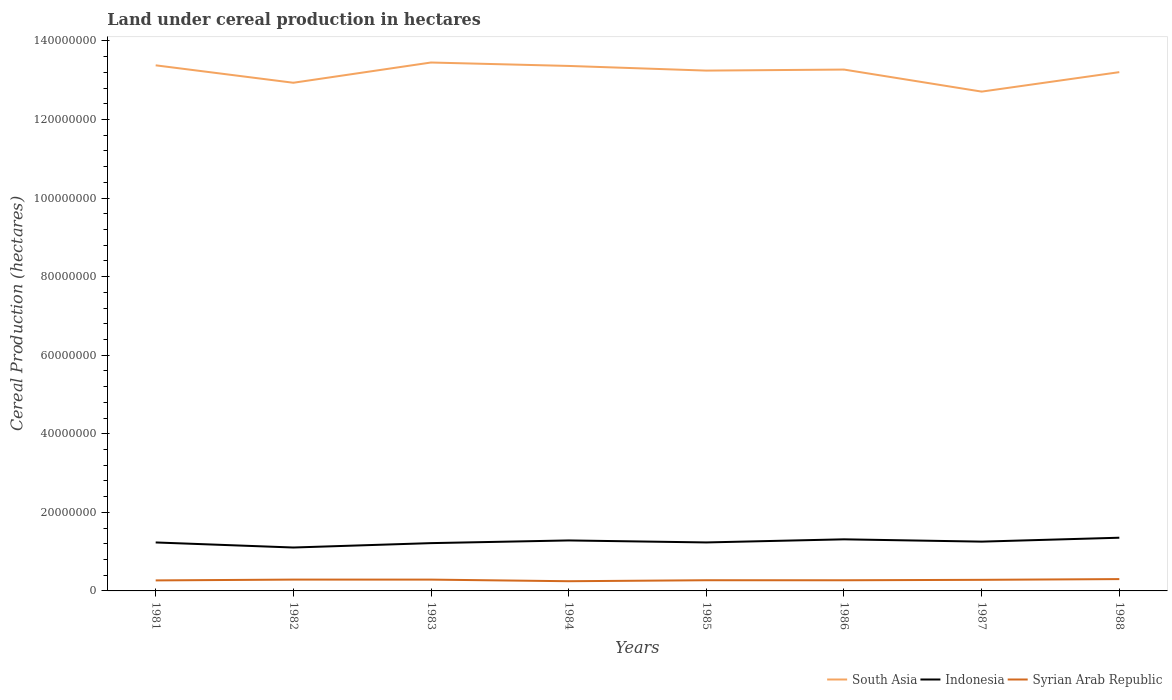Across all years, what is the maximum land under cereal production in South Asia?
Your answer should be compact. 1.27e+08. What is the total land under cereal production in South Asia in the graph?
Make the answer very short. 6.69e+06. What is the difference between the highest and the second highest land under cereal production in Indonesia?
Your answer should be compact. 2.49e+06. Is the land under cereal production in Indonesia strictly greater than the land under cereal production in South Asia over the years?
Your answer should be compact. Yes. How many lines are there?
Give a very brief answer. 3. How many years are there in the graph?
Your response must be concise. 8. What is the difference between two consecutive major ticks on the Y-axis?
Give a very brief answer. 2.00e+07. Does the graph contain any zero values?
Your answer should be very brief. No. Where does the legend appear in the graph?
Give a very brief answer. Bottom right. How are the legend labels stacked?
Give a very brief answer. Horizontal. What is the title of the graph?
Provide a succinct answer. Land under cereal production in hectares. Does "South Africa" appear as one of the legend labels in the graph?
Provide a succinct answer. No. What is the label or title of the X-axis?
Offer a very short reply. Years. What is the label or title of the Y-axis?
Your response must be concise. Cereal Production (hectares). What is the Cereal Production (hectares) in South Asia in 1981?
Offer a very short reply. 1.34e+08. What is the Cereal Production (hectares) in Indonesia in 1981?
Make the answer very short. 1.23e+07. What is the Cereal Production (hectares) of Syrian Arab Republic in 1981?
Keep it short and to the point. 2.68e+06. What is the Cereal Production (hectares) of South Asia in 1982?
Offer a very short reply. 1.29e+08. What is the Cereal Production (hectares) in Indonesia in 1982?
Your answer should be very brief. 1.10e+07. What is the Cereal Production (hectares) of Syrian Arab Republic in 1982?
Your answer should be compact. 2.88e+06. What is the Cereal Production (hectares) of South Asia in 1983?
Provide a short and direct response. 1.35e+08. What is the Cereal Production (hectares) in Indonesia in 1983?
Provide a short and direct response. 1.22e+07. What is the Cereal Production (hectares) of Syrian Arab Republic in 1983?
Provide a succinct answer. 2.88e+06. What is the Cereal Production (hectares) of South Asia in 1984?
Your response must be concise. 1.34e+08. What is the Cereal Production (hectares) in Indonesia in 1984?
Provide a short and direct response. 1.28e+07. What is the Cereal Production (hectares) of Syrian Arab Republic in 1984?
Your answer should be very brief. 2.47e+06. What is the Cereal Production (hectares) of South Asia in 1985?
Provide a succinct answer. 1.32e+08. What is the Cereal Production (hectares) of Indonesia in 1985?
Make the answer very short. 1.23e+07. What is the Cereal Production (hectares) of Syrian Arab Republic in 1985?
Provide a short and direct response. 2.72e+06. What is the Cereal Production (hectares) of South Asia in 1986?
Provide a succinct answer. 1.33e+08. What is the Cereal Production (hectares) in Indonesia in 1986?
Give a very brief answer. 1.31e+07. What is the Cereal Production (hectares) in Syrian Arab Republic in 1986?
Ensure brevity in your answer.  2.71e+06. What is the Cereal Production (hectares) in South Asia in 1987?
Keep it short and to the point. 1.27e+08. What is the Cereal Production (hectares) in Indonesia in 1987?
Give a very brief answer. 1.25e+07. What is the Cereal Production (hectares) of Syrian Arab Republic in 1987?
Give a very brief answer. 2.82e+06. What is the Cereal Production (hectares) of South Asia in 1988?
Keep it short and to the point. 1.32e+08. What is the Cereal Production (hectares) in Indonesia in 1988?
Keep it short and to the point. 1.35e+07. What is the Cereal Production (hectares) in Syrian Arab Republic in 1988?
Offer a terse response. 3.01e+06. Across all years, what is the maximum Cereal Production (hectares) of South Asia?
Your answer should be compact. 1.35e+08. Across all years, what is the maximum Cereal Production (hectares) in Indonesia?
Your answer should be very brief. 1.35e+07. Across all years, what is the maximum Cereal Production (hectares) of Syrian Arab Republic?
Provide a short and direct response. 3.01e+06. Across all years, what is the minimum Cereal Production (hectares) of South Asia?
Your answer should be compact. 1.27e+08. Across all years, what is the minimum Cereal Production (hectares) in Indonesia?
Offer a terse response. 1.10e+07. Across all years, what is the minimum Cereal Production (hectares) in Syrian Arab Republic?
Make the answer very short. 2.47e+06. What is the total Cereal Production (hectares) of South Asia in the graph?
Offer a very short reply. 1.06e+09. What is the total Cereal Production (hectares) of Indonesia in the graph?
Keep it short and to the point. 1.00e+08. What is the total Cereal Production (hectares) in Syrian Arab Republic in the graph?
Keep it short and to the point. 2.22e+07. What is the difference between the Cereal Production (hectares) in South Asia in 1981 and that in 1982?
Ensure brevity in your answer.  4.44e+06. What is the difference between the Cereal Production (hectares) of Indonesia in 1981 and that in 1982?
Provide a succinct answer. 1.29e+06. What is the difference between the Cereal Production (hectares) of Syrian Arab Republic in 1981 and that in 1982?
Your answer should be compact. -2.07e+05. What is the difference between the Cereal Production (hectares) in South Asia in 1981 and that in 1983?
Offer a terse response. -7.17e+05. What is the difference between the Cereal Production (hectares) of Indonesia in 1981 and that in 1983?
Offer a terse response. 1.72e+05. What is the difference between the Cereal Production (hectares) of Syrian Arab Republic in 1981 and that in 1983?
Provide a short and direct response. -2.04e+05. What is the difference between the Cereal Production (hectares) in South Asia in 1981 and that in 1984?
Give a very brief answer. 1.54e+05. What is the difference between the Cereal Production (hectares) of Indonesia in 1981 and that in 1984?
Your answer should be compact. -5.13e+05. What is the difference between the Cereal Production (hectares) of Syrian Arab Republic in 1981 and that in 1984?
Your response must be concise. 2.05e+05. What is the difference between the Cereal Production (hectares) in South Asia in 1981 and that in 1985?
Keep it short and to the point. 1.34e+06. What is the difference between the Cereal Production (hectares) of Indonesia in 1981 and that in 1985?
Your answer should be very brief. -5381. What is the difference between the Cereal Production (hectares) of Syrian Arab Republic in 1981 and that in 1985?
Your answer should be compact. -4.33e+04. What is the difference between the Cereal Production (hectares) in South Asia in 1981 and that in 1986?
Your answer should be very brief. 1.08e+06. What is the difference between the Cereal Production (hectares) in Indonesia in 1981 and that in 1986?
Your answer should be very brief. -7.94e+05. What is the difference between the Cereal Production (hectares) of Syrian Arab Republic in 1981 and that in 1986?
Make the answer very short. -3.76e+04. What is the difference between the Cereal Production (hectares) in South Asia in 1981 and that in 1987?
Provide a succinct answer. 6.69e+06. What is the difference between the Cereal Production (hectares) in Indonesia in 1981 and that in 1987?
Offer a very short reply. -2.12e+05. What is the difference between the Cereal Production (hectares) in Syrian Arab Republic in 1981 and that in 1987?
Ensure brevity in your answer.  -1.48e+05. What is the difference between the Cereal Production (hectares) in South Asia in 1981 and that in 1988?
Your response must be concise. 1.73e+06. What is the difference between the Cereal Production (hectares) of Indonesia in 1981 and that in 1988?
Give a very brief answer. -1.21e+06. What is the difference between the Cereal Production (hectares) of Syrian Arab Republic in 1981 and that in 1988?
Give a very brief answer. -3.36e+05. What is the difference between the Cereal Production (hectares) in South Asia in 1982 and that in 1983?
Give a very brief answer. -5.15e+06. What is the difference between the Cereal Production (hectares) of Indonesia in 1982 and that in 1983?
Provide a succinct answer. -1.11e+06. What is the difference between the Cereal Production (hectares) of Syrian Arab Republic in 1982 and that in 1983?
Ensure brevity in your answer.  2786. What is the difference between the Cereal Production (hectares) of South Asia in 1982 and that in 1984?
Ensure brevity in your answer.  -4.28e+06. What is the difference between the Cereal Production (hectares) of Indonesia in 1982 and that in 1984?
Provide a short and direct response. -1.80e+06. What is the difference between the Cereal Production (hectares) of Syrian Arab Republic in 1982 and that in 1984?
Keep it short and to the point. 4.11e+05. What is the difference between the Cereal Production (hectares) of South Asia in 1982 and that in 1985?
Ensure brevity in your answer.  -3.10e+06. What is the difference between the Cereal Production (hectares) of Indonesia in 1982 and that in 1985?
Make the answer very short. -1.29e+06. What is the difference between the Cereal Production (hectares) in Syrian Arab Republic in 1982 and that in 1985?
Your response must be concise. 1.63e+05. What is the difference between the Cereal Production (hectares) of South Asia in 1982 and that in 1986?
Ensure brevity in your answer.  -3.36e+06. What is the difference between the Cereal Production (hectares) of Indonesia in 1982 and that in 1986?
Ensure brevity in your answer.  -2.08e+06. What is the difference between the Cereal Production (hectares) of Syrian Arab Republic in 1982 and that in 1986?
Provide a succinct answer. 1.69e+05. What is the difference between the Cereal Production (hectares) in South Asia in 1982 and that in 1987?
Keep it short and to the point. 2.25e+06. What is the difference between the Cereal Production (hectares) in Indonesia in 1982 and that in 1987?
Provide a succinct answer. -1.50e+06. What is the difference between the Cereal Production (hectares) of Syrian Arab Republic in 1982 and that in 1987?
Keep it short and to the point. 5.90e+04. What is the difference between the Cereal Production (hectares) in South Asia in 1982 and that in 1988?
Provide a short and direct response. -2.70e+06. What is the difference between the Cereal Production (hectares) in Indonesia in 1982 and that in 1988?
Offer a terse response. -2.49e+06. What is the difference between the Cereal Production (hectares) of Syrian Arab Republic in 1982 and that in 1988?
Your response must be concise. -1.29e+05. What is the difference between the Cereal Production (hectares) in South Asia in 1983 and that in 1984?
Make the answer very short. 8.71e+05. What is the difference between the Cereal Production (hectares) of Indonesia in 1983 and that in 1984?
Your answer should be compact. -6.85e+05. What is the difference between the Cereal Production (hectares) of Syrian Arab Republic in 1983 and that in 1984?
Your answer should be compact. 4.09e+05. What is the difference between the Cereal Production (hectares) in South Asia in 1983 and that in 1985?
Offer a very short reply. 2.06e+06. What is the difference between the Cereal Production (hectares) in Indonesia in 1983 and that in 1985?
Provide a succinct answer. -1.78e+05. What is the difference between the Cereal Production (hectares) in Syrian Arab Republic in 1983 and that in 1985?
Make the answer very short. 1.60e+05. What is the difference between the Cereal Production (hectares) in South Asia in 1983 and that in 1986?
Provide a succinct answer. 1.79e+06. What is the difference between the Cereal Production (hectares) in Indonesia in 1983 and that in 1986?
Your response must be concise. -9.67e+05. What is the difference between the Cereal Production (hectares) in Syrian Arab Republic in 1983 and that in 1986?
Provide a short and direct response. 1.66e+05. What is the difference between the Cereal Production (hectares) in South Asia in 1983 and that in 1987?
Provide a succinct answer. 7.41e+06. What is the difference between the Cereal Production (hectares) in Indonesia in 1983 and that in 1987?
Your answer should be very brief. -3.84e+05. What is the difference between the Cereal Production (hectares) in Syrian Arab Republic in 1983 and that in 1987?
Your response must be concise. 5.62e+04. What is the difference between the Cereal Production (hectares) in South Asia in 1983 and that in 1988?
Your answer should be compact. 2.45e+06. What is the difference between the Cereal Production (hectares) in Indonesia in 1983 and that in 1988?
Offer a terse response. -1.38e+06. What is the difference between the Cereal Production (hectares) in Syrian Arab Republic in 1983 and that in 1988?
Your response must be concise. -1.32e+05. What is the difference between the Cereal Production (hectares) of South Asia in 1984 and that in 1985?
Make the answer very short. 1.19e+06. What is the difference between the Cereal Production (hectares) of Indonesia in 1984 and that in 1985?
Keep it short and to the point. 5.08e+05. What is the difference between the Cereal Production (hectares) of Syrian Arab Republic in 1984 and that in 1985?
Provide a short and direct response. -2.48e+05. What is the difference between the Cereal Production (hectares) of South Asia in 1984 and that in 1986?
Your response must be concise. 9.24e+05. What is the difference between the Cereal Production (hectares) of Indonesia in 1984 and that in 1986?
Offer a terse response. -2.81e+05. What is the difference between the Cereal Production (hectares) in Syrian Arab Republic in 1984 and that in 1986?
Your answer should be compact. -2.42e+05. What is the difference between the Cereal Production (hectares) of South Asia in 1984 and that in 1987?
Offer a very short reply. 6.54e+06. What is the difference between the Cereal Production (hectares) in Indonesia in 1984 and that in 1987?
Your response must be concise. 3.01e+05. What is the difference between the Cereal Production (hectares) in Syrian Arab Republic in 1984 and that in 1987?
Make the answer very short. -3.52e+05. What is the difference between the Cereal Production (hectares) of South Asia in 1984 and that in 1988?
Make the answer very short. 1.58e+06. What is the difference between the Cereal Production (hectares) in Indonesia in 1984 and that in 1988?
Make the answer very short. -6.94e+05. What is the difference between the Cereal Production (hectares) in Syrian Arab Republic in 1984 and that in 1988?
Your answer should be compact. -5.41e+05. What is the difference between the Cereal Production (hectares) of South Asia in 1985 and that in 1986?
Your response must be concise. -2.65e+05. What is the difference between the Cereal Production (hectares) in Indonesia in 1985 and that in 1986?
Offer a very short reply. -7.89e+05. What is the difference between the Cereal Production (hectares) in Syrian Arab Republic in 1985 and that in 1986?
Give a very brief answer. 5741. What is the difference between the Cereal Production (hectares) of South Asia in 1985 and that in 1987?
Offer a very short reply. 5.35e+06. What is the difference between the Cereal Production (hectares) in Indonesia in 1985 and that in 1987?
Your response must be concise. -2.06e+05. What is the difference between the Cereal Production (hectares) of Syrian Arab Republic in 1985 and that in 1987?
Offer a terse response. -1.04e+05. What is the difference between the Cereal Production (hectares) of South Asia in 1985 and that in 1988?
Offer a terse response. 3.92e+05. What is the difference between the Cereal Production (hectares) in Indonesia in 1985 and that in 1988?
Provide a succinct answer. -1.20e+06. What is the difference between the Cereal Production (hectares) of Syrian Arab Republic in 1985 and that in 1988?
Offer a very short reply. -2.92e+05. What is the difference between the Cereal Production (hectares) in South Asia in 1986 and that in 1987?
Offer a very short reply. 5.61e+06. What is the difference between the Cereal Production (hectares) of Indonesia in 1986 and that in 1987?
Your answer should be very brief. 5.83e+05. What is the difference between the Cereal Production (hectares) in Syrian Arab Republic in 1986 and that in 1987?
Provide a succinct answer. -1.10e+05. What is the difference between the Cereal Production (hectares) of South Asia in 1986 and that in 1988?
Your answer should be compact. 6.57e+05. What is the difference between the Cereal Production (hectares) in Indonesia in 1986 and that in 1988?
Make the answer very short. -4.13e+05. What is the difference between the Cereal Production (hectares) of Syrian Arab Republic in 1986 and that in 1988?
Offer a very short reply. -2.98e+05. What is the difference between the Cereal Production (hectares) in South Asia in 1987 and that in 1988?
Offer a terse response. -4.96e+06. What is the difference between the Cereal Production (hectares) in Indonesia in 1987 and that in 1988?
Your answer should be compact. -9.95e+05. What is the difference between the Cereal Production (hectares) of Syrian Arab Republic in 1987 and that in 1988?
Your answer should be compact. -1.88e+05. What is the difference between the Cereal Production (hectares) of South Asia in 1981 and the Cereal Production (hectares) of Indonesia in 1982?
Provide a succinct answer. 1.23e+08. What is the difference between the Cereal Production (hectares) of South Asia in 1981 and the Cereal Production (hectares) of Syrian Arab Republic in 1982?
Keep it short and to the point. 1.31e+08. What is the difference between the Cereal Production (hectares) in Indonesia in 1981 and the Cereal Production (hectares) in Syrian Arab Republic in 1982?
Offer a very short reply. 9.45e+06. What is the difference between the Cereal Production (hectares) in South Asia in 1981 and the Cereal Production (hectares) in Indonesia in 1983?
Your answer should be compact. 1.22e+08. What is the difference between the Cereal Production (hectares) in South Asia in 1981 and the Cereal Production (hectares) in Syrian Arab Republic in 1983?
Your response must be concise. 1.31e+08. What is the difference between the Cereal Production (hectares) in Indonesia in 1981 and the Cereal Production (hectares) in Syrian Arab Republic in 1983?
Give a very brief answer. 9.46e+06. What is the difference between the Cereal Production (hectares) in South Asia in 1981 and the Cereal Production (hectares) in Indonesia in 1984?
Give a very brief answer. 1.21e+08. What is the difference between the Cereal Production (hectares) of South Asia in 1981 and the Cereal Production (hectares) of Syrian Arab Republic in 1984?
Provide a succinct answer. 1.31e+08. What is the difference between the Cereal Production (hectares) of Indonesia in 1981 and the Cereal Production (hectares) of Syrian Arab Republic in 1984?
Give a very brief answer. 9.87e+06. What is the difference between the Cereal Production (hectares) of South Asia in 1981 and the Cereal Production (hectares) of Indonesia in 1985?
Provide a short and direct response. 1.21e+08. What is the difference between the Cereal Production (hectares) in South Asia in 1981 and the Cereal Production (hectares) in Syrian Arab Republic in 1985?
Make the answer very short. 1.31e+08. What is the difference between the Cereal Production (hectares) in Indonesia in 1981 and the Cereal Production (hectares) in Syrian Arab Republic in 1985?
Make the answer very short. 9.62e+06. What is the difference between the Cereal Production (hectares) of South Asia in 1981 and the Cereal Production (hectares) of Indonesia in 1986?
Your answer should be very brief. 1.21e+08. What is the difference between the Cereal Production (hectares) of South Asia in 1981 and the Cereal Production (hectares) of Syrian Arab Republic in 1986?
Provide a succinct answer. 1.31e+08. What is the difference between the Cereal Production (hectares) in Indonesia in 1981 and the Cereal Production (hectares) in Syrian Arab Republic in 1986?
Your response must be concise. 9.62e+06. What is the difference between the Cereal Production (hectares) in South Asia in 1981 and the Cereal Production (hectares) in Indonesia in 1987?
Provide a short and direct response. 1.21e+08. What is the difference between the Cereal Production (hectares) of South Asia in 1981 and the Cereal Production (hectares) of Syrian Arab Republic in 1987?
Make the answer very short. 1.31e+08. What is the difference between the Cereal Production (hectares) of Indonesia in 1981 and the Cereal Production (hectares) of Syrian Arab Republic in 1987?
Your answer should be compact. 9.51e+06. What is the difference between the Cereal Production (hectares) of South Asia in 1981 and the Cereal Production (hectares) of Indonesia in 1988?
Your response must be concise. 1.20e+08. What is the difference between the Cereal Production (hectares) of South Asia in 1981 and the Cereal Production (hectares) of Syrian Arab Republic in 1988?
Your answer should be compact. 1.31e+08. What is the difference between the Cereal Production (hectares) of Indonesia in 1981 and the Cereal Production (hectares) of Syrian Arab Republic in 1988?
Your answer should be compact. 9.32e+06. What is the difference between the Cereal Production (hectares) in South Asia in 1982 and the Cereal Production (hectares) in Indonesia in 1983?
Provide a succinct answer. 1.17e+08. What is the difference between the Cereal Production (hectares) in South Asia in 1982 and the Cereal Production (hectares) in Syrian Arab Republic in 1983?
Give a very brief answer. 1.26e+08. What is the difference between the Cereal Production (hectares) in Indonesia in 1982 and the Cereal Production (hectares) in Syrian Arab Republic in 1983?
Make the answer very short. 8.17e+06. What is the difference between the Cereal Production (hectares) of South Asia in 1982 and the Cereal Production (hectares) of Indonesia in 1984?
Keep it short and to the point. 1.16e+08. What is the difference between the Cereal Production (hectares) of South Asia in 1982 and the Cereal Production (hectares) of Syrian Arab Republic in 1984?
Ensure brevity in your answer.  1.27e+08. What is the difference between the Cereal Production (hectares) of Indonesia in 1982 and the Cereal Production (hectares) of Syrian Arab Republic in 1984?
Offer a terse response. 8.58e+06. What is the difference between the Cereal Production (hectares) in South Asia in 1982 and the Cereal Production (hectares) in Indonesia in 1985?
Offer a terse response. 1.17e+08. What is the difference between the Cereal Production (hectares) in South Asia in 1982 and the Cereal Production (hectares) in Syrian Arab Republic in 1985?
Provide a short and direct response. 1.27e+08. What is the difference between the Cereal Production (hectares) of Indonesia in 1982 and the Cereal Production (hectares) of Syrian Arab Republic in 1985?
Provide a succinct answer. 8.33e+06. What is the difference between the Cereal Production (hectares) in South Asia in 1982 and the Cereal Production (hectares) in Indonesia in 1986?
Ensure brevity in your answer.  1.16e+08. What is the difference between the Cereal Production (hectares) in South Asia in 1982 and the Cereal Production (hectares) in Syrian Arab Republic in 1986?
Offer a terse response. 1.27e+08. What is the difference between the Cereal Production (hectares) in Indonesia in 1982 and the Cereal Production (hectares) in Syrian Arab Republic in 1986?
Provide a short and direct response. 8.34e+06. What is the difference between the Cereal Production (hectares) in South Asia in 1982 and the Cereal Production (hectares) in Indonesia in 1987?
Ensure brevity in your answer.  1.17e+08. What is the difference between the Cereal Production (hectares) of South Asia in 1982 and the Cereal Production (hectares) of Syrian Arab Republic in 1987?
Your response must be concise. 1.27e+08. What is the difference between the Cereal Production (hectares) of Indonesia in 1982 and the Cereal Production (hectares) of Syrian Arab Republic in 1987?
Keep it short and to the point. 8.23e+06. What is the difference between the Cereal Production (hectares) of South Asia in 1982 and the Cereal Production (hectares) of Indonesia in 1988?
Provide a short and direct response. 1.16e+08. What is the difference between the Cereal Production (hectares) of South Asia in 1982 and the Cereal Production (hectares) of Syrian Arab Republic in 1988?
Provide a succinct answer. 1.26e+08. What is the difference between the Cereal Production (hectares) of Indonesia in 1982 and the Cereal Production (hectares) of Syrian Arab Republic in 1988?
Provide a short and direct response. 8.04e+06. What is the difference between the Cereal Production (hectares) of South Asia in 1983 and the Cereal Production (hectares) of Indonesia in 1984?
Offer a very short reply. 1.22e+08. What is the difference between the Cereal Production (hectares) in South Asia in 1983 and the Cereal Production (hectares) in Syrian Arab Republic in 1984?
Make the answer very short. 1.32e+08. What is the difference between the Cereal Production (hectares) in Indonesia in 1983 and the Cereal Production (hectares) in Syrian Arab Republic in 1984?
Provide a short and direct response. 9.69e+06. What is the difference between the Cereal Production (hectares) in South Asia in 1983 and the Cereal Production (hectares) in Indonesia in 1985?
Provide a succinct answer. 1.22e+08. What is the difference between the Cereal Production (hectares) of South Asia in 1983 and the Cereal Production (hectares) of Syrian Arab Republic in 1985?
Your answer should be very brief. 1.32e+08. What is the difference between the Cereal Production (hectares) of Indonesia in 1983 and the Cereal Production (hectares) of Syrian Arab Republic in 1985?
Keep it short and to the point. 9.45e+06. What is the difference between the Cereal Production (hectares) in South Asia in 1983 and the Cereal Production (hectares) in Indonesia in 1986?
Offer a very short reply. 1.21e+08. What is the difference between the Cereal Production (hectares) in South Asia in 1983 and the Cereal Production (hectares) in Syrian Arab Republic in 1986?
Your answer should be compact. 1.32e+08. What is the difference between the Cereal Production (hectares) in Indonesia in 1983 and the Cereal Production (hectares) in Syrian Arab Republic in 1986?
Ensure brevity in your answer.  9.45e+06. What is the difference between the Cereal Production (hectares) in South Asia in 1983 and the Cereal Production (hectares) in Indonesia in 1987?
Provide a succinct answer. 1.22e+08. What is the difference between the Cereal Production (hectares) of South Asia in 1983 and the Cereal Production (hectares) of Syrian Arab Republic in 1987?
Offer a terse response. 1.32e+08. What is the difference between the Cereal Production (hectares) in Indonesia in 1983 and the Cereal Production (hectares) in Syrian Arab Republic in 1987?
Your response must be concise. 9.34e+06. What is the difference between the Cereal Production (hectares) of South Asia in 1983 and the Cereal Production (hectares) of Indonesia in 1988?
Offer a very short reply. 1.21e+08. What is the difference between the Cereal Production (hectares) in South Asia in 1983 and the Cereal Production (hectares) in Syrian Arab Republic in 1988?
Keep it short and to the point. 1.31e+08. What is the difference between the Cereal Production (hectares) of Indonesia in 1983 and the Cereal Production (hectares) of Syrian Arab Republic in 1988?
Your answer should be very brief. 9.15e+06. What is the difference between the Cereal Production (hectares) in South Asia in 1984 and the Cereal Production (hectares) in Indonesia in 1985?
Offer a terse response. 1.21e+08. What is the difference between the Cereal Production (hectares) in South Asia in 1984 and the Cereal Production (hectares) in Syrian Arab Republic in 1985?
Give a very brief answer. 1.31e+08. What is the difference between the Cereal Production (hectares) in Indonesia in 1984 and the Cereal Production (hectares) in Syrian Arab Republic in 1985?
Give a very brief answer. 1.01e+07. What is the difference between the Cereal Production (hectares) of South Asia in 1984 and the Cereal Production (hectares) of Indonesia in 1986?
Offer a terse response. 1.21e+08. What is the difference between the Cereal Production (hectares) in South Asia in 1984 and the Cereal Production (hectares) in Syrian Arab Republic in 1986?
Give a very brief answer. 1.31e+08. What is the difference between the Cereal Production (hectares) of Indonesia in 1984 and the Cereal Production (hectares) of Syrian Arab Republic in 1986?
Provide a short and direct response. 1.01e+07. What is the difference between the Cereal Production (hectares) in South Asia in 1984 and the Cereal Production (hectares) in Indonesia in 1987?
Ensure brevity in your answer.  1.21e+08. What is the difference between the Cereal Production (hectares) in South Asia in 1984 and the Cereal Production (hectares) in Syrian Arab Republic in 1987?
Offer a terse response. 1.31e+08. What is the difference between the Cereal Production (hectares) of Indonesia in 1984 and the Cereal Production (hectares) of Syrian Arab Republic in 1987?
Your response must be concise. 1.00e+07. What is the difference between the Cereal Production (hectares) of South Asia in 1984 and the Cereal Production (hectares) of Indonesia in 1988?
Ensure brevity in your answer.  1.20e+08. What is the difference between the Cereal Production (hectares) of South Asia in 1984 and the Cereal Production (hectares) of Syrian Arab Republic in 1988?
Offer a terse response. 1.31e+08. What is the difference between the Cereal Production (hectares) of Indonesia in 1984 and the Cereal Production (hectares) of Syrian Arab Republic in 1988?
Give a very brief answer. 9.84e+06. What is the difference between the Cereal Production (hectares) of South Asia in 1985 and the Cereal Production (hectares) of Indonesia in 1986?
Your answer should be compact. 1.19e+08. What is the difference between the Cereal Production (hectares) in South Asia in 1985 and the Cereal Production (hectares) in Syrian Arab Republic in 1986?
Your answer should be compact. 1.30e+08. What is the difference between the Cereal Production (hectares) of Indonesia in 1985 and the Cereal Production (hectares) of Syrian Arab Republic in 1986?
Your response must be concise. 9.63e+06. What is the difference between the Cereal Production (hectares) in South Asia in 1985 and the Cereal Production (hectares) in Indonesia in 1987?
Give a very brief answer. 1.20e+08. What is the difference between the Cereal Production (hectares) of South Asia in 1985 and the Cereal Production (hectares) of Syrian Arab Republic in 1987?
Your answer should be very brief. 1.30e+08. What is the difference between the Cereal Production (hectares) of Indonesia in 1985 and the Cereal Production (hectares) of Syrian Arab Republic in 1987?
Your answer should be very brief. 9.52e+06. What is the difference between the Cereal Production (hectares) of South Asia in 1985 and the Cereal Production (hectares) of Indonesia in 1988?
Offer a very short reply. 1.19e+08. What is the difference between the Cereal Production (hectares) of South Asia in 1985 and the Cereal Production (hectares) of Syrian Arab Republic in 1988?
Give a very brief answer. 1.29e+08. What is the difference between the Cereal Production (hectares) of Indonesia in 1985 and the Cereal Production (hectares) of Syrian Arab Republic in 1988?
Provide a short and direct response. 9.33e+06. What is the difference between the Cereal Production (hectares) in South Asia in 1986 and the Cereal Production (hectares) in Indonesia in 1987?
Make the answer very short. 1.20e+08. What is the difference between the Cereal Production (hectares) of South Asia in 1986 and the Cereal Production (hectares) of Syrian Arab Republic in 1987?
Your response must be concise. 1.30e+08. What is the difference between the Cereal Production (hectares) of Indonesia in 1986 and the Cereal Production (hectares) of Syrian Arab Republic in 1987?
Your answer should be very brief. 1.03e+07. What is the difference between the Cereal Production (hectares) in South Asia in 1986 and the Cereal Production (hectares) in Indonesia in 1988?
Your answer should be very brief. 1.19e+08. What is the difference between the Cereal Production (hectares) of South Asia in 1986 and the Cereal Production (hectares) of Syrian Arab Republic in 1988?
Your response must be concise. 1.30e+08. What is the difference between the Cereal Production (hectares) in Indonesia in 1986 and the Cereal Production (hectares) in Syrian Arab Republic in 1988?
Give a very brief answer. 1.01e+07. What is the difference between the Cereal Production (hectares) in South Asia in 1987 and the Cereal Production (hectares) in Indonesia in 1988?
Offer a very short reply. 1.14e+08. What is the difference between the Cereal Production (hectares) in South Asia in 1987 and the Cereal Production (hectares) in Syrian Arab Republic in 1988?
Keep it short and to the point. 1.24e+08. What is the difference between the Cereal Production (hectares) of Indonesia in 1987 and the Cereal Production (hectares) of Syrian Arab Republic in 1988?
Your answer should be very brief. 9.54e+06. What is the average Cereal Production (hectares) of South Asia per year?
Keep it short and to the point. 1.32e+08. What is the average Cereal Production (hectares) of Indonesia per year?
Your response must be concise. 1.25e+07. What is the average Cereal Production (hectares) of Syrian Arab Republic per year?
Keep it short and to the point. 2.77e+06. In the year 1981, what is the difference between the Cereal Production (hectares) of South Asia and Cereal Production (hectares) of Indonesia?
Provide a short and direct response. 1.21e+08. In the year 1981, what is the difference between the Cereal Production (hectares) of South Asia and Cereal Production (hectares) of Syrian Arab Republic?
Provide a succinct answer. 1.31e+08. In the year 1981, what is the difference between the Cereal Production (hectares) in Indonesia and Cereal Production (hectares) in Syrian Arab Republic?
Your answer should be very brief. 9.66e+06. In the year 1982, what is the difference between the Cereal Production (hectares) in South Asia and Cereal Production (hectares) in Indonesia?
Your answer should be very brief. 1.18e+08. In the year 1982, what is the difference between the Cereal Production (hectares) of South Asia and Cereal Production (hectares) of Syrian Arab Republic?
Ensure brevity in your answer.  1.26e+08. In the year 1982, what is the difference between the Cereal Production (hectares) in Indonesia and Cereal Production (hectares) in Syrian Arab Republic?
Ensure brevity in your answer.  8.17e+06. In the year 1983, what is the difference between the Cereal Production (hectares) of South Asia and Cereal Production (hectares) of Indonesia?
Your answer should be compact. 1.22e+08. In the year 1983, what is the difference between the Cereal Production (hectares) in South Asia and Cereal Production (hectares) in Syrian Arab Republic?
Make the answer very short. 1.32e+08. In the year 1983, what is the difference between the Cereal Production (hectares) in Indonesia and Cereal Production (hectares) in Syrian Arab Republic?
Provide a succinct answer. 9.28e+06. In the year 1984, what is the difference between the Cereal Production (hectares) of South Asia and Cereal Production (hectares) of Indonesia?
Offer a very short reply. 1.21e+08. In the year 1984, what is the difference between the Cereal Production (hectares) in South Asia and Cereal Production (hectares) in Syrian Arab Republic?
Provide a short and direct response. 1.31e+08. In the year 1984, what is the difference between the Cereal Production (hectares) in Indonesia and Cereal Production (hectares) in Syrian Arab Republic?
Give a very brief answer. 1.04e+07. In the year 1985, what is the difference between the Cereal Production (hectares) of South Asia and Cereal Production (hectares) of Indonesia?
Offer a very short reply. 1.20e+08. In the year 1985, what is the difference between the Cereal Production (hectares) in South Asia and Cereal Production (hectares) in Syrian Arab Republic?
Make the answer very short. 1.30e+08. In the year 1985, what is the difference between the Cereal Production (hectares) in Indonesia and Cereal Production (hectares) in Syrian Arab Republic?
Your answer should be compact. 9.62e+06. In the year 1986, what is the difference between the Cereal Production (hectares) in South Asia and Cereal Production (hectares) in Indonesia?
Give a very brief answer. 1.20e+08. In the year 1986, what is the difference between the Cereal Production (hectares) of South Asia and Cereal Production (hectares) of Syrian Arab Republic?
Your answer should be very brief. 1.30e+08. In the year 1986, what is the difference between the Cereal Production (hectares) of Indonesia and Cereal Production (hectares) of Syrian Arab Republic?
Ensure brevity in your answer.  1.04e+07. In the year 1987, what is the difference between the Cereal Production (hectares) of South Asia and Cereal Production (hectares) of Indonesia?
Give a very brief answer. 1.15e+08. In the year 1987, what is the difference between the Cereal Production (hectares) of South Asia and Cereal Production (hectares) of Syrian Arab Republic?
Provide a short and direct response. 1.24e+08. In the year 1987, what is the difference between the Cereal Production (hectares) of Indonesia and Cereal Production (hectares) of Syrian Arab Republic?
Your answer should be compact. 9.72e+06. In the year 1988, what is the difference between the Cereal Production (hectares) of South Asia and Cereal Production (hectares) of Indonesia?
Ensure brevity in your answer.  1.19e+08. In the year 1988, what is the difference between the Cereal Production (hectares) of South Asia and Cereal Production (hectares) of Syrian Arab Republic?
Give a very brief answer. 1.29e+08. In the year 1988, what is the difference between the Cereal Production (hectares) of Indonesia and Cereal Production (hectares) of Syrian Arab Republic?
Your answer should be compact. 1.05e+07. What is the ratio of the Cereal Production (hectares) of South Asia in 1981 to that in 1982?
Give a very brief answer. 1.03. What is the ratio of the Cereal Production (hectares) in Indonesia in 1981 to that in 1982?
Your answer should be compact. 1.12. What is the ratio of the Cereal Production (hectares) in Syrian Arab Republic in 1981 to that in 1982?
Keep it short and to the point. 0.93. What is the ratio of the Cereal Production (hectares) of Indonesia in 1981 to that in 1983?
Offer a very short reply. 1.01. What is the ratio of the Cereal Production (hectares) of Syrian Arab Republic in 1981 to that in 1983?
Keep it short and to the point. 0.93. What is the ratio of the Cereal Production (hectares) in Indonesia in 1981 to that in 1984?
Provide a short and direct response. 0.96. What is the ratio of the Cereal Production (hectares) in Syrian Arab Republic in 1981 to that in 1984?
Ensure brevity in your answer.  1.08. What is the ratio of the Cereal Production (hectares) in South Asia in 1981 to that in 1985?
Make the answer very short. 1.01. What is the ratio of the Cereal Production (hectares) of Indonesia in 1981 to that in 1985?
Offer a very short reply. 1. What is the ratio of the Cereal Production (hectares) of Syrian Arab Republic in 1981 to that in 1985?
Ensure brevity in your answer.  0.98. What is the ratio of the Cereal Production (hectares) of Indonesia in 1981 to that in 1986?
Your answer should be very brief. 0.94. What is the ratio of the Cereal Production (hectares) of Syrian Arab Republic in 1981 to that in 1986?
Make the answer very short. 0.99. What is the ratio of the Cereal Production (hectares) in South Asia in 1981 to that in 1987?
Offer a terse response. 1.05. What is the ratio of the Cereal Production (hectares) in Indonesia in 1981 to that in 1987?
Your answer should be very brief. 0.98. What is the ratio of the Cereal Production (hectares) in Syrian Arab Republic in 1981 to that in 1987?
Provide a short and direct response. 0.95. What is the ratio of the Cereal Production (hectares) in South Asia in 1981 to that in 1988?
Offer a terse response. 1.01. What is the ratio of the Cereal Production (hectares) in Indonesia in 1981 to that in 1988?
Your answer should be compact. 0.91. What is the ratio of the Cereal Production (hectares) in Syrian Arab Republic in 1981 to that in 1988?
Give a very brief answer. 0.89. What is the ratio of the Cereal Production (hectares) in South Asia in 1982 to that in 1983?
Your answer should be compact. 0.96. What is the ratio of the Cereal Production (hectares) in Indonesia in 1982 to that in 1983?
Offer a terse response. 0.91. What is the ratio of the Cereal Production (hectares) in South Asia in 1982 to that in 1984?
Provide a succinct answer. 0.97. What is the ratio of the Cereal Production (hectares) of Indonesia in 1982 to that in 1984?
Give a very brief answer. 0.86. What is the ratio of the Cereal Production (hectares) of Syrian Arab Republic in 1982 to that in 1984?
Provide a succinct answer. 1.17. What is the ratio of the Cereal Production (hectares) in South Asia in 1982 to that in 1985?
Ensure brevity in your answer.  0.98. What is the ratio of the Cereal Production (hectares) in Indonesia in 1982 to that in 1985?
Offer a terse response. 0.9. What is the ratio of the Cereal Production (hectares) of Syrian Arab Republic in 1982 to that in 1985?
Make the answer very short. 1.06. What is the ratio of the Cereal Production (hectares) of South Asia in 1982 to that in 1986?
Your answer should be very brief. 0.97. What is the ratio of the Cereal Production (hectares) of Indonesia in 1982 to that in 1986?
Your response must be concise. 0.84. What is the ratio of the Cereal Production (hectares) in Syrian Arab Republic in 1982 to that in 1986?
Provide a succinct answer. 1.06. What is the ratio of the Cereal Production (hectares) in South Asia in 1982 to that in 1987?
Your answer should be compact. 1.02. What is the ratio of the Cereal Production (hectares) of Indonesia in 1982 to that in 1987?
Offer a very short reply. 0.88. What is the ratio of the Cereal Production (hectares) in Syrian Arab Republic in 1982 to that in 1987?
Your response must be concise. 1.02. What is the ratio of the Cereal Production (hectares) of South Asia in 1982 to that in 1988?
Offer a terse response. 0.98. What is the ratio of the Cereal Production (hectares) of Indonesia in 1982 to that in 1988?
Offer a terse response. 0.82. What is the ratio of the Cereal Production (hectares) of Syrian Arab Republic in 1982 to that in 1988?
Give a very brief answer. 0.96. What is the ratio of the Cereal Production (hectares) of Indonesia in 1983 to that in 1984?
Your response must be concise. 0.95. What is the ratio of the Cereal Production (hectares) of Syrian Arab Republic in 1983 to that in 1984?
Your answer should be very brief. 1.17. What is the ratio of the Cereal Production (hectares) in South Asia in 1983 to that in 1985?
Keep it short and to the point. 1.02. What is the ratio of the Cereal Production (hectares) of Indonesia in 1983 to that in 1985?
Provide a short and direct response. 0.99. What is the ratio of the Cereal Production (hectares) in Syrian Arab Republic in 1983 to that in 1985?
Ensure brevity in your answer.  1.06. What is the ratio of the Cereal Production (hectares) of South Asia in 1983 to that in 1986?
Ensure brevity in your answer.  1.01. What is the ratio of the Cereal Production (hectares) in Indonesia in 1983 to that in 1986?
Your response must be concise. 0.93. What is the ratio of the Cereal Production (hectares) of Syrian Arab Republic in 1983 to that in 1986?
Your answer should be compact. 1.06. What is the ratio of the Cereal Production (hectares) of South Asia in 1983 to that in 1987?
Your answer should be compact. 1.06. What is the ratio of the Cereal Production (hectares) of Indonesia in 1983 to that in 1987?
Your answer should be compact. 0.97. What is the ratio of the Cereal Production (hectares) of Syrian Arab Republic in 1983 to that in 1987?
Your response must be concise. 1.02. What is the ratio of the Cereal Production (hectares) in South Asia in 1983 to that in 1988?
Your answer should be very brief. 1.02. What is the ratio of the Cereal Production (hectares) of Indonesia in 1983 to that in 1988?
Give a very brief answer. 0.9. What is the ratio of the Cereal Production (hectares) in Syrian Arab Republic in 1983 to that in 1988?
Your answer should be very brief. 0.96. What is the ratio of the Cereal Production (hectares) of South Asia in 1984 to that in 1985?
Your answer should be compact. 1.01. What is the ratio of the Cereal Production (hectares) in Indonesia in 1984 to that in 1985?
Give a very brief answer. 1.04. What is the ratio of the Cereal Production (hectares) in Syrian Arab Republic in 1984 to that in 1985?
Keep it short and to the point. 0.91. What is the ratio of the Cereal Production (hectares) in Indonesia in 1984 to that in 1986?
Your answer should be compact. 0.98. What is the ratio of the Cereal Production (hectares) of Syrian Arab Republic in 1984 to that in 1986?
Offer a terse response. 0.91. What is the ratio of the Cereal Production (hectares) of South Asia in 1984 to that in 1987?
Give a very brief answer. 1.05. What is the ratio of the Cereal Production (hectares) of Syrian Arab Republic in 1984 to that in 1987?
Your answer should be very brief. 0.88. What is the ratio of the Cereal Production (hectares) of Indonesia in 1984 to that in 1988?
Offer a terse response. 0.95. What is the ratio of the Cereal Production (hectares) of Syrian Arab Republic in 1984 to that in 1988?
Your response must be concise. 0.82. What is the ratio of the Cereal Production (hectares) of South Asia in 1985 to that in 1986?
Provide a short and direct response. 1. What is the ratio of the Cereal Production (hectares) of Indonesia in 1985 to that in 1986?
Ensure brevity in your answer.  0.94. What is the ratio of the Cereal Production (hectares) of Syrian Arab Republic in 1985 to that in 1986?
Offer a terse response. 1. What is the ratio of the Cereal Production (hectares) of South Asia in 1985 to that in 1987?
Make the answer very short. 1.04. What is the ratio of the Cereal Production (hectares) in Indonesia in 1985 to that in 1987?
Provide a succinct answer. 0.98. What is the ratio of the Cereal Production (hectares) of Syrian Arab Republic in 1985 to that in 1987?
Your answer should be compact. 0.96. What is the ratio of the Cereal Production (hectares) in Indonesia in 1985 to that in 1988?
Your response must be concise. 0.91. What is the ratio of the Cereal Production (hectares) of Syrian Arab Republic in 1985 to that in 1988?
Provide a short and direct response. 0.9. What is the ratio of the Cereal Production (hectares) in South Asia in 1986 to that in 1987?
Provide a short and direct response. 1.04. What is the ratio of the Cereal Production (hectares) in Indonesia in 1986 to that in 1987?
Keep it short and to the point. 1.05. What is the ratio of the Cereal Production (hectares) of Syrian Arab Republic in 1986 to that in 1987?
Ensure brevity in your answer.  0.96. What is the ratio of the Cereal Production (hectares) of South Asia in 1986 to that in 1988?
Ensure brevity in your answer.  1. What is the ratio of the Cereal Production (hectares) in Indonesia in 1986 to that in 1988?
Your response must be concise. 0.97. What is the ratio of the Cereal Production (hectares) of Syrian Arab Republic in 1986 to that in 1988?
Your response must be concise. 0.9. What is the ratio of the Cereal Production (hectares) in South Asia in 1987 to that in 1988?
Ensure brevity in your answer.  0.96. What is the ratio of the Cereal Production (hectares) of Indonesia in 1987 to that in 1988?
Provide a short and direct response. 0.93. What is the ratio of the Cereal Production (hectares) in Syrian Arab Republic in 1987 to that in 1988?
Provide a succinct answer. 0.94. What is the difference between the highest and the second highest Cereal Production (hectares) of South Asia?
Offer a very short reply. 7.17e+05. What is the difference between the highest and the second highest Cereal Production (hectares) in Indonesia?
Give a very brief answer. 4.13e+05. What is the difference between the highest and the second highest Cereal Production (hectares) of Syrian Arab Republic?
Offer a terse response. 1.29e+05. What is the difference between the highest and the lowest Cereal Production (hectares) in South Asia?
Provide a succinct answer. 7.41e+06. What is the difference between the highest and the lowest Cereal Production (hectares) of Indonesia?
Keep it short and to the point. 2.49e+06. What is the difference between the highest and the lowest Cereal Production (hectares) in Syrian Arab Republic?
Give a very brief answer. 5.41e+05. 